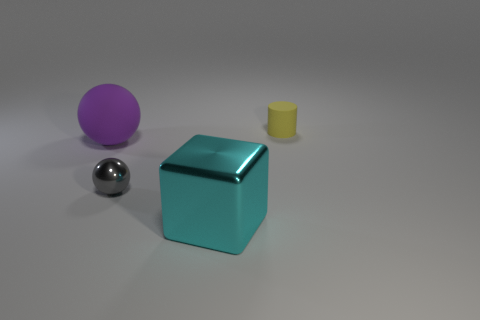Add 2 tiny green shiny blocks. How many objects exist? 6 Subtract all cubes. How many objects are left? 3 Subtract all purple matte cylinders. Subtract all small objects. How many objects are left? 2 Add 2 large purple things. How many large purple things are left? 3 Add 1 big metal things. How many big metal things exist? 2 Subtract 0 red blocks. How many objects are left? 4 Subtract all purple cylinders. Subtract all green balls. How many cylinders are left? 1 Subtract all green cubes. How many purple balls are left? 1 